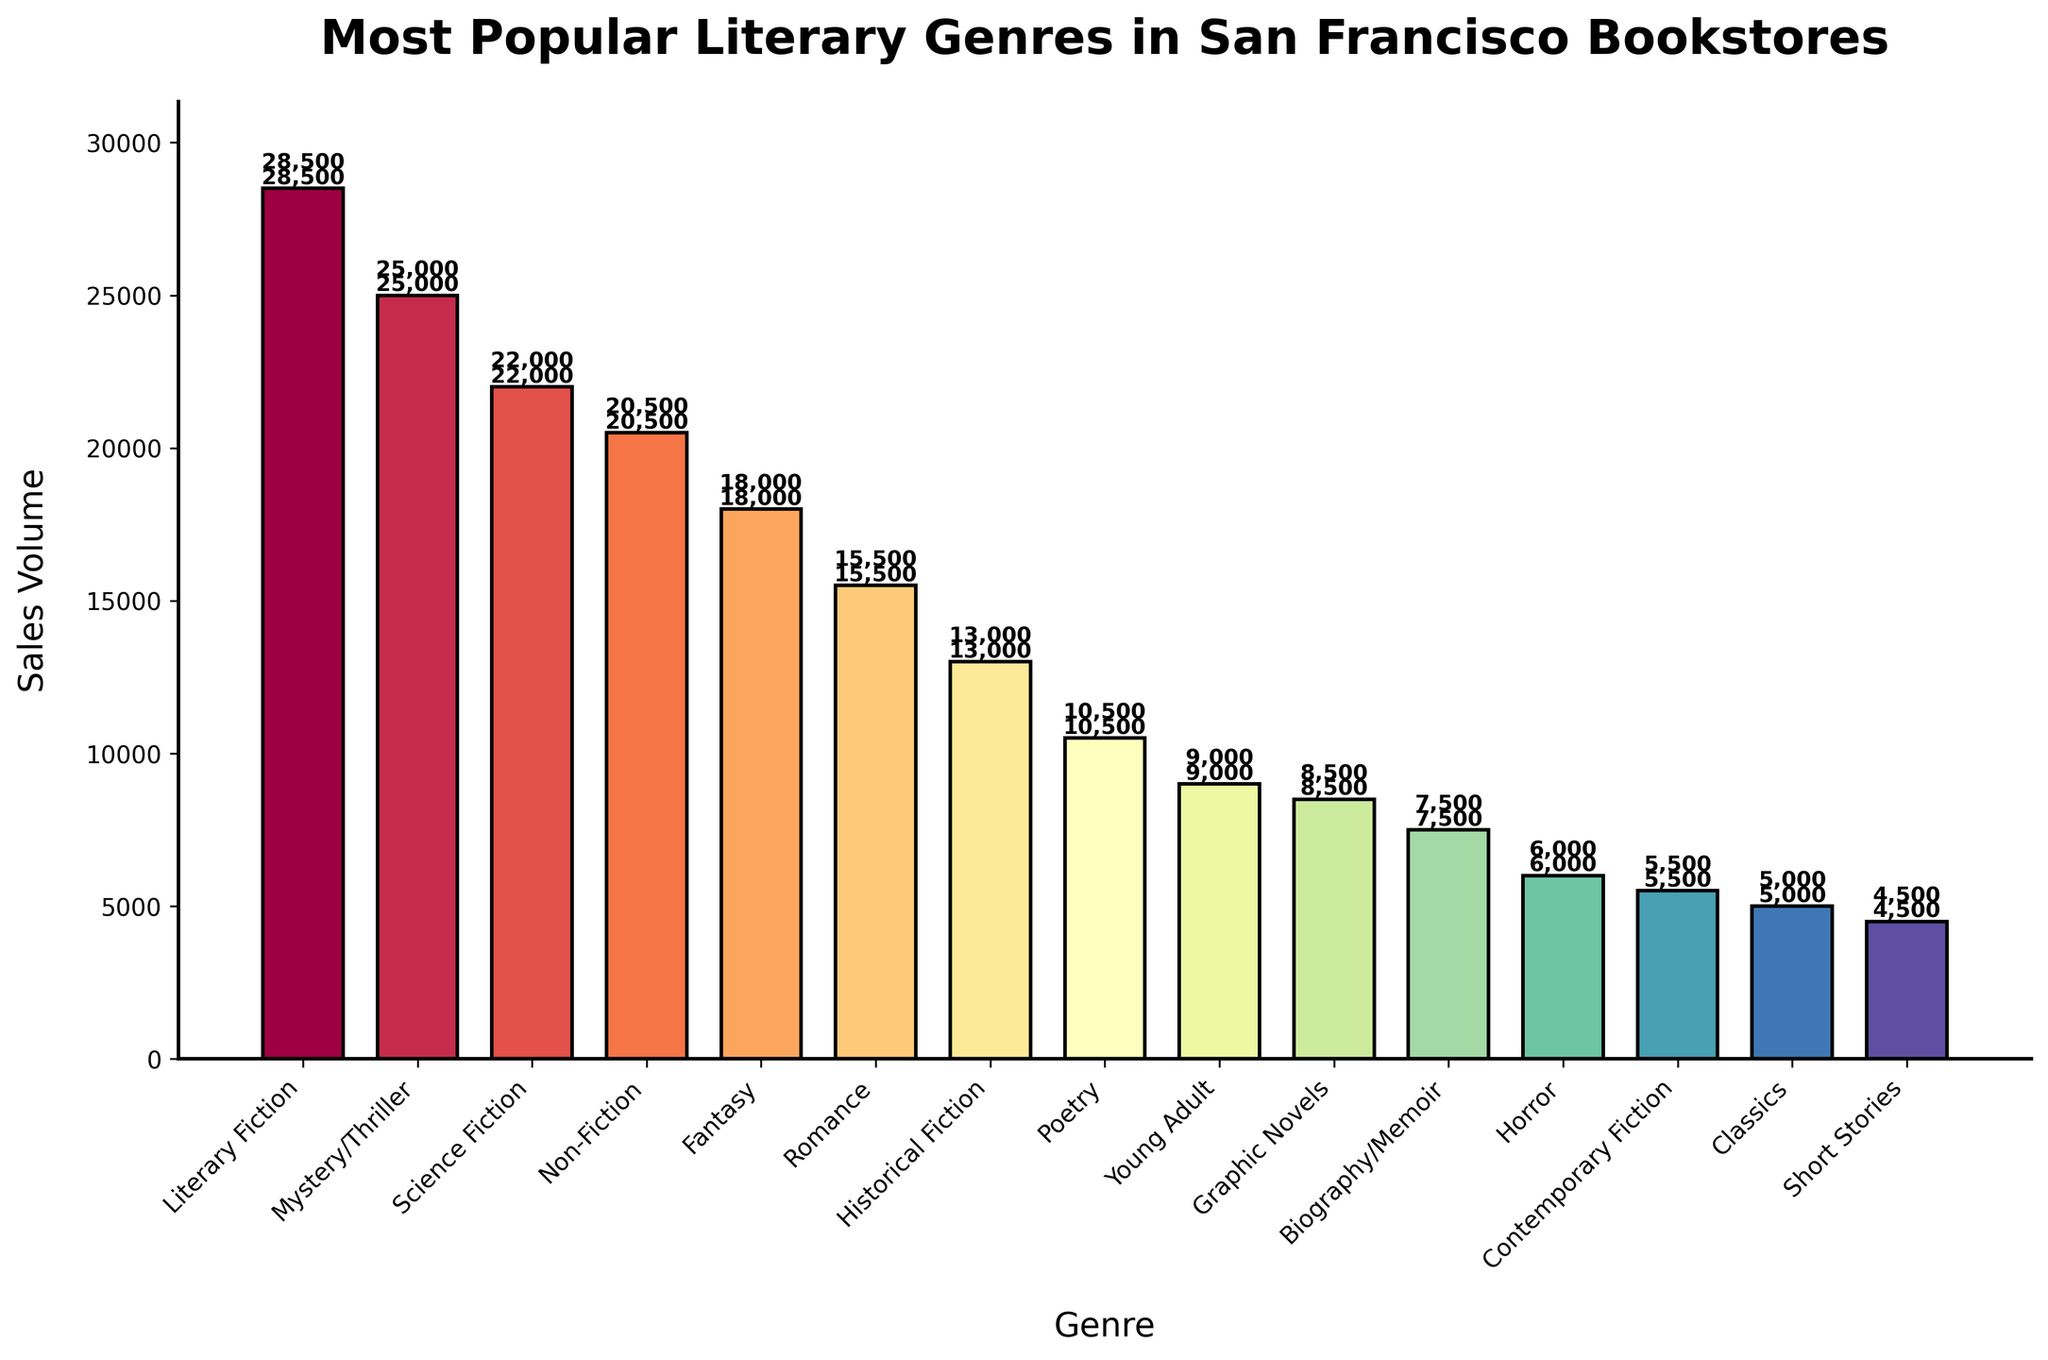Which genre has the highest sales volume? By looking at the height of the bars, the Literary Fiction genre has the highest sales volume.
Answer: Literary Fiction Which genre has the lowest sales volume? By observing the shortest bar in the figure, the Short Stories genre has the lowest sales volume.
Answer: Short Stories How much higher are the sales of Literary Fiction compared to Contemporary Fiction? The sales volume for Literary Fiction is 28,500 and Contemporary Fiction is 5,500. The difference is 28,500 - 5,500 = 23,000.
Answer: 23,000 What is the total sales volume of the top 3 genres? The top 3 genres by sales volume are Literary Fiction, Mystery/Thriller, and Science Fiction with sales of 28,500, 25,000, and 22,000 respectively. The total is 28,500 + 25,000 + 22,000 = 75,500.
Answer: 75,500 Which genre has a higher sales volume, Poetry or Fantasy? By comparing the bars, we see that the sales volume for Fantasy (18,000) is higher than Poetry (10,500).
Answer: Fantasy What is the average sales volume of the Non-Fiction and Biography/Memoir genres? The sales volume for Non-Fiction is 20,500 and for Biography/Memoir is 7,500. The average is (20,500 + 7,500) / 2 = 14,000.
Answer: 14,000 Which genre is positioned between Fantasy and Young Adult in terms of sales volume? The genres in descending order are Fantasy (18,000), Romance (15,500), and Historical Fiction (13,000) before reaching Young Adult (9,000). Therefore, Romance is between Fantasy and Young Adult.
Answer: Romance What is the difference in sales volume between the highest and the lowest-selling genres? The highest sales volume is Literary Fiction with 28,500 and the lowest is Short Stories with 4,500. The difference is 28,500 - 4,500 = 24,000.
Answer: 24,000 What is the median sales volume of all the genres? To find the median, we list the sales volumes in ascending order: 4,500, 5,000, 5,500, 6,000, 7,500, 8,500, 9,000, 10,500, 13,000, 15,500, 18,000, 20,500, 22,000, 25,000, 28,500. The median value (the middle one) is 10,500.
Answer: 10,500 